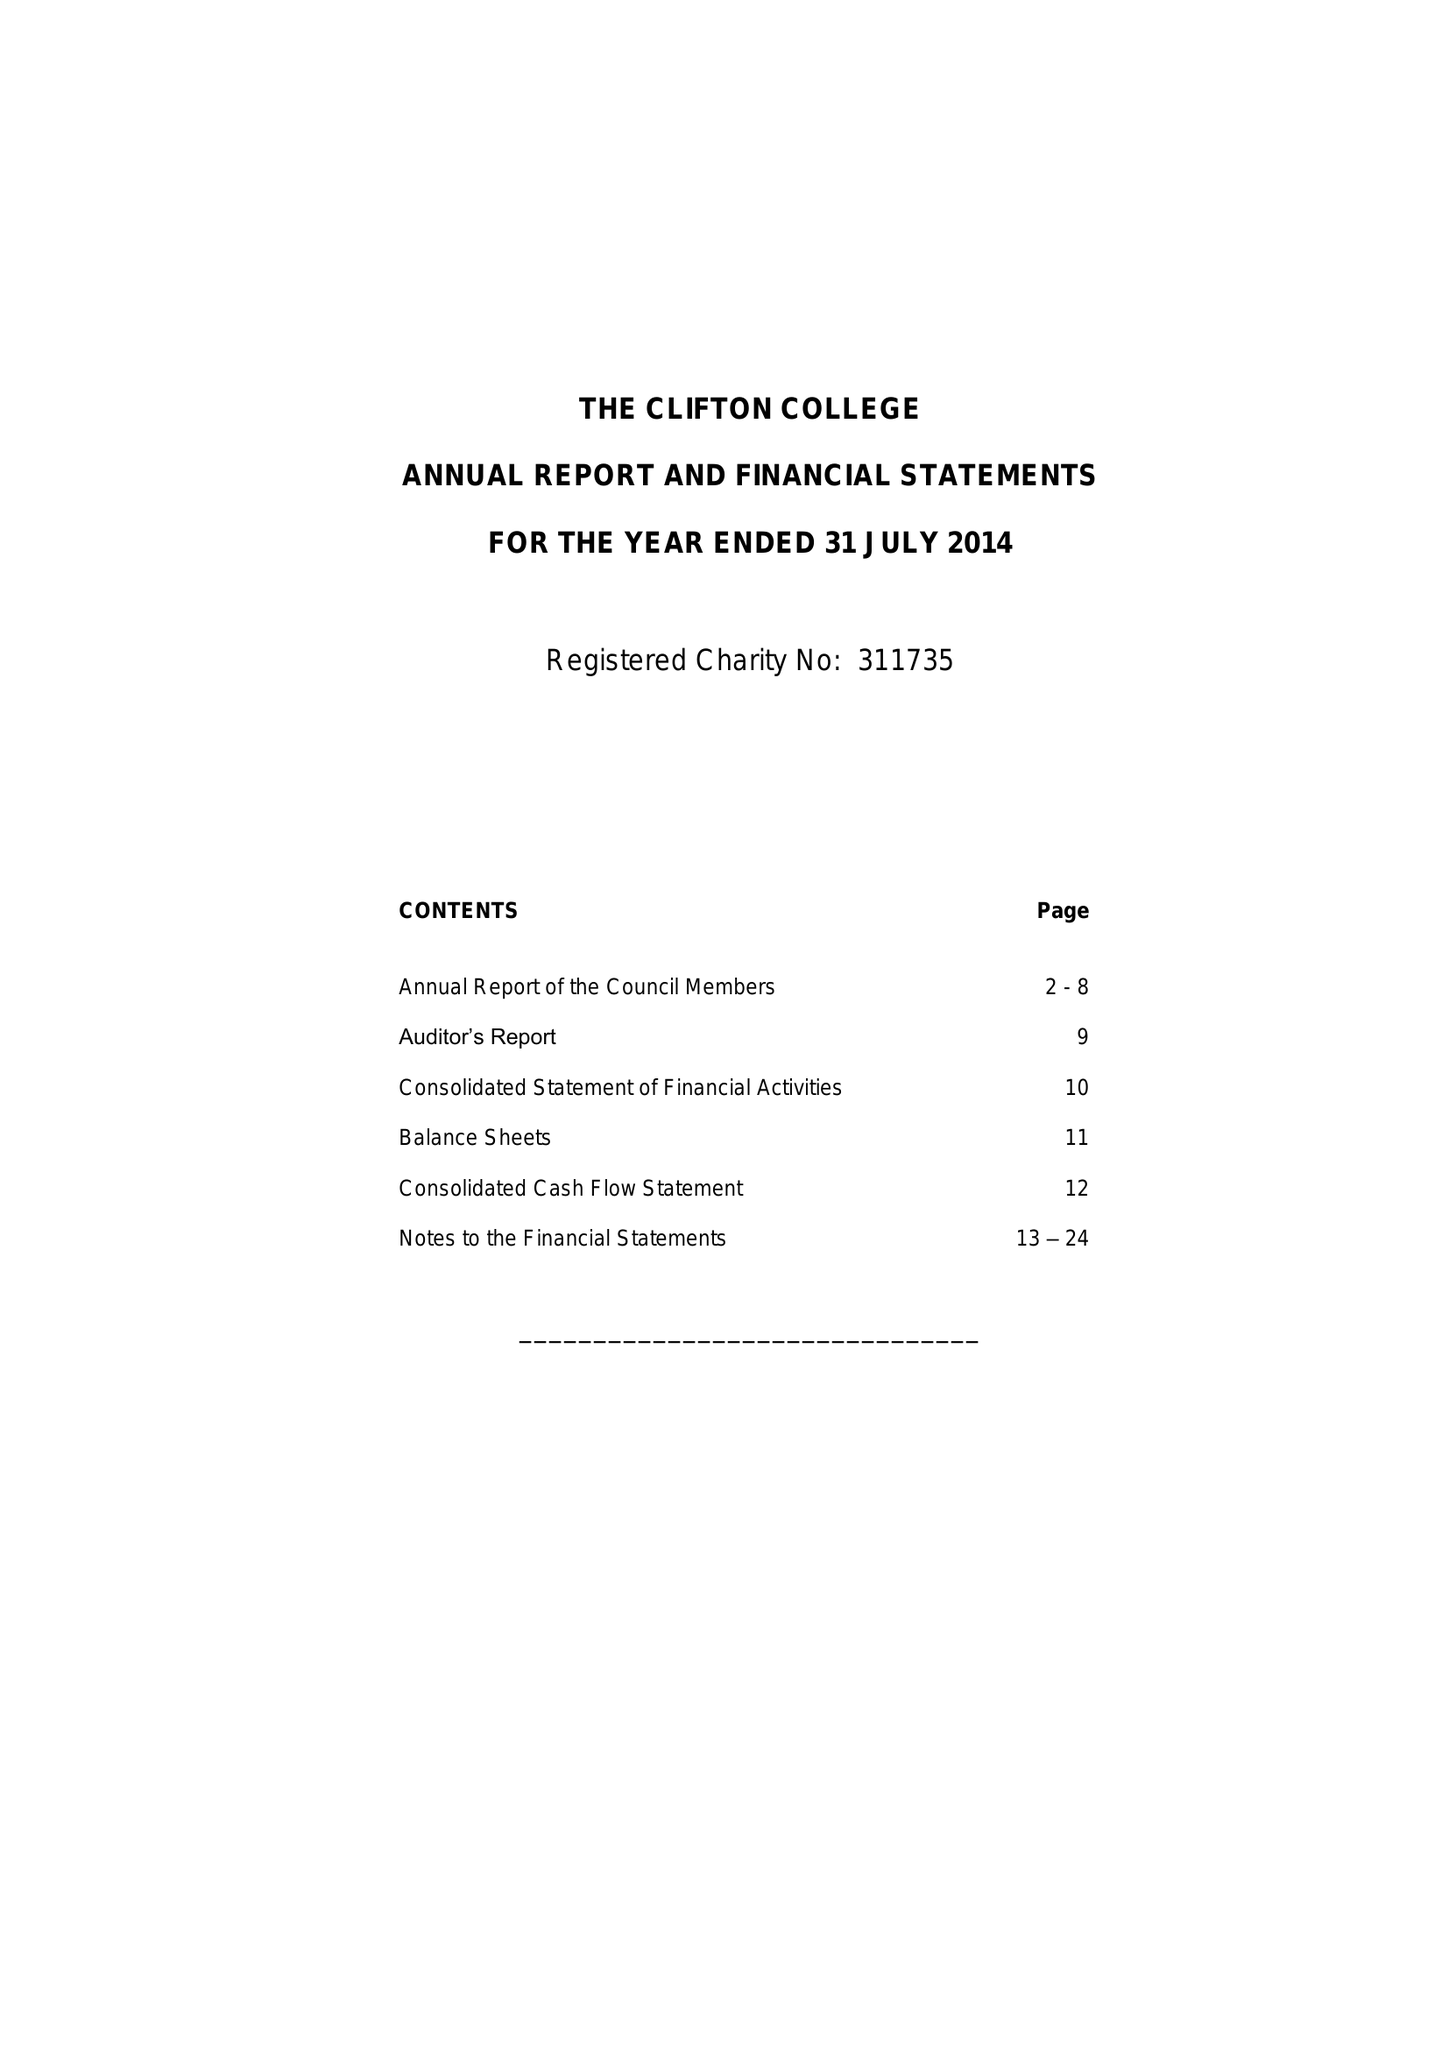What is the value for the charity_name?
Answer the question using a single word or phrase. Clifton College 